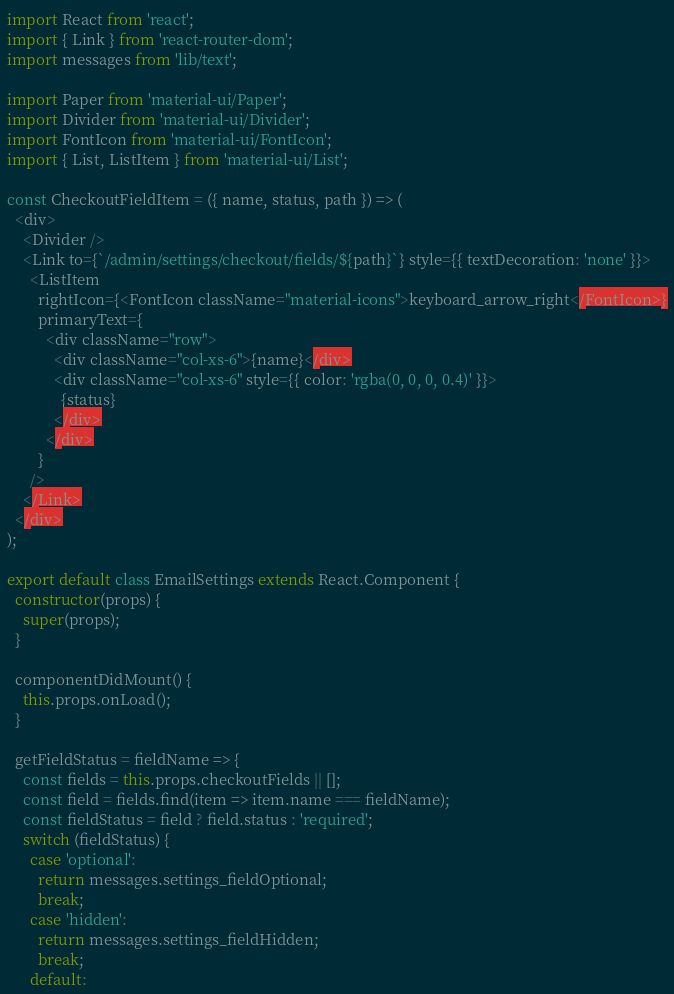Convert code to text. <code><loc_0><loc_0><loc_500><loc_500><_JavaScript_>import React from 'react';
import { Link } from 'react-router-dom';
import messages from 'lib/text';

import Paper from 'material-ui/Paper';
import Divider from 'material-ui/Divider';
import FontIcon from 'material-ui/FontIcon';
import { List, ListItem } from 'material-ui/List';

const CheckoutFieldItem = ({ name, status, path }) => (
  <div>
    <Divider />
    <Link to={`/admin/settings/checkout/fields/${path}`} style={{ textDecoration: 'none' }}>
      <ListItem
        rightIcon={<FontIcon className="material-icons">keyboard_arrow_right</FontIcon>}
        primaryText={
          <div className="row">
            <div className="col-xs-6">{name}</div>
            <div className="col-xs-6" style={{ color: 'rgba(0, 0, 0, 0.4)' }}>
              {status}
            </div>
          </div>
        }
      />
    </Link>
  </div>
);

export default class EmailSettings extends React.Component {
  constructor(props) {
    super(props);
  }

  componentDidMount() {
    this.props.onLoad();
  }

  getFieldStatus = fieldName => {
    const fields = this.props.checkoutFields || [];
    const field = fields.find(item => item.name === fieldName);
    const fieldStatus = field ? field.status : 'required';
    switch (fieldStatus) {
      case 'optional':
        return messages.settings_fieldOptional;
        break;
      case 'hidden':
        return messages.settings_fieldHidden;
        break;
      default:</code> 